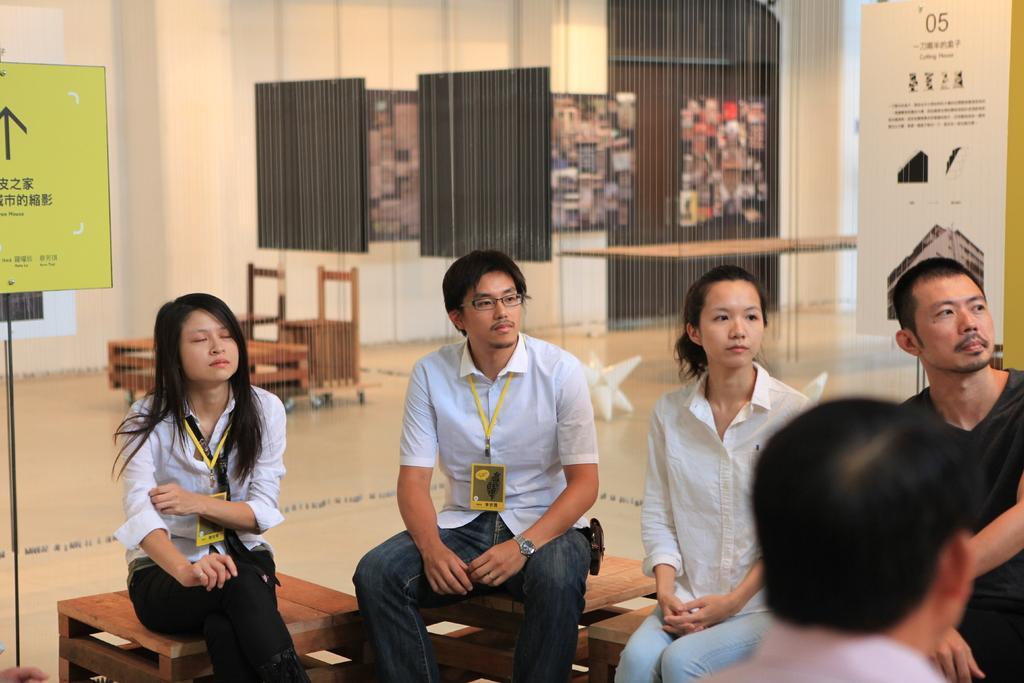How many people are in the image? There is a group of people in the image, but the exact number cannot be determined from the provided facts. What are some of the people in the image doing? Some people are sitting in the image. What can be seen in the background of the image? There is a poster, a chair, a table, and a wall in the background, along with other objects. What type of boot is being used to play a game in the image? There is no boot or game present in the image; it features a group of people and various objects in the background. 